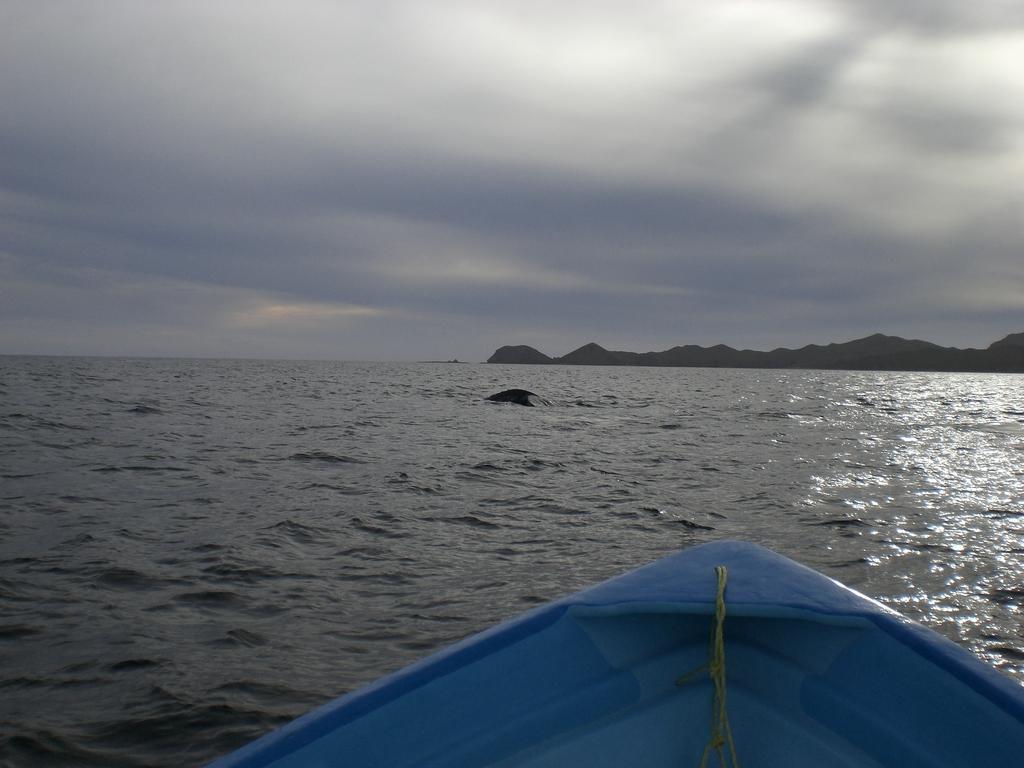Could you give a brief overview of what you see in this image? In this picture in the front there is a boat sailing on the water which is blue in colour. In the center there is an ocean. In the background there are mountains and the sky is cloudy. 